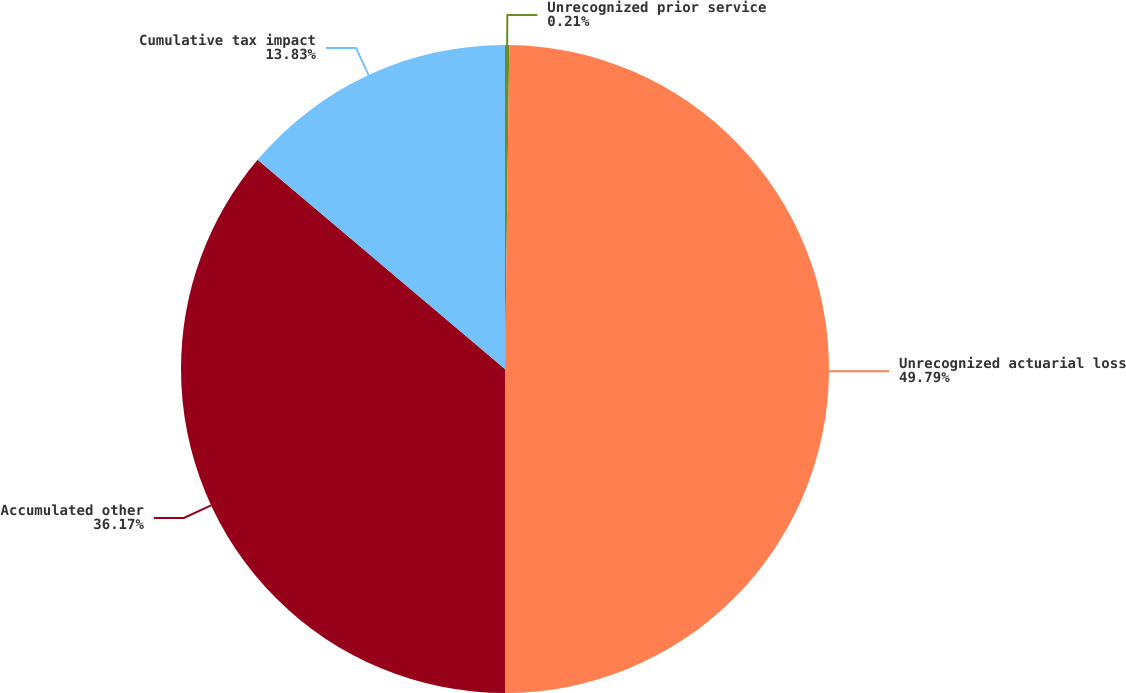Convert chart. <chart><loc_0><loc_0><loc_500><loc_500><pie_chart><fcel>Unrecognized prior service<fcel>Unrecognized actuarial loss<fcel>Accumulated other<fcel>Cumulative tax impact<nl><fcel>0.21%<fcel>49.79%<fcel>36.17%<fcel>13.83%<nl></chart> 